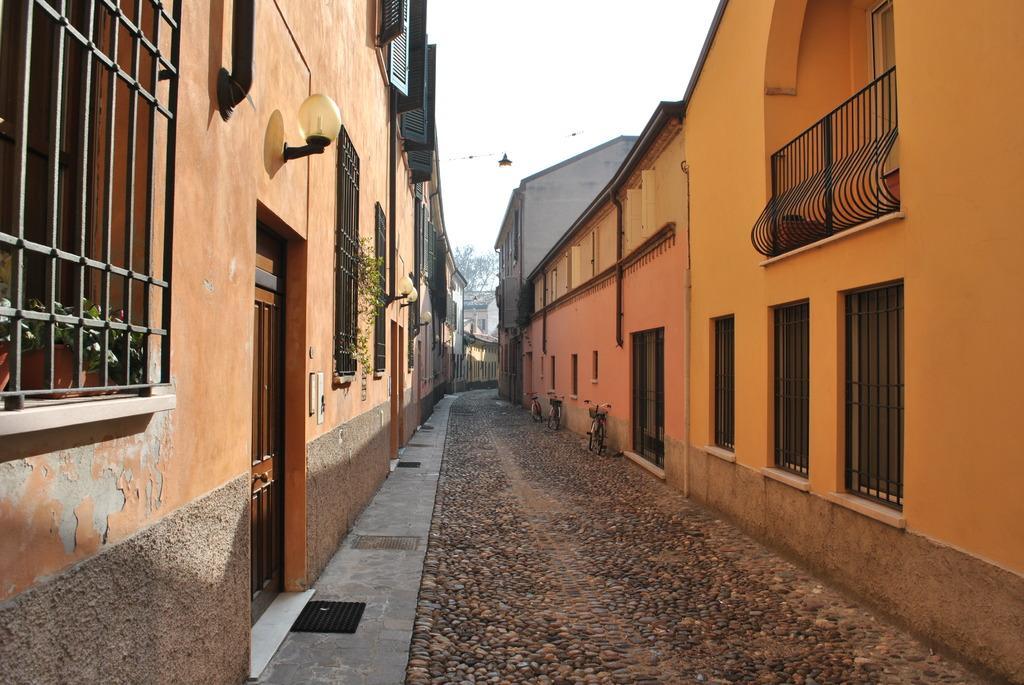Please provide a concise description of this image. In this image we can see the path in the middle and there are bicycles on the path at the wall. To either side of the path there are buildings and we can see windows, doors, mesh gates, plants,lights and pipes on the walls. In the background there is a building, tree and sky. 